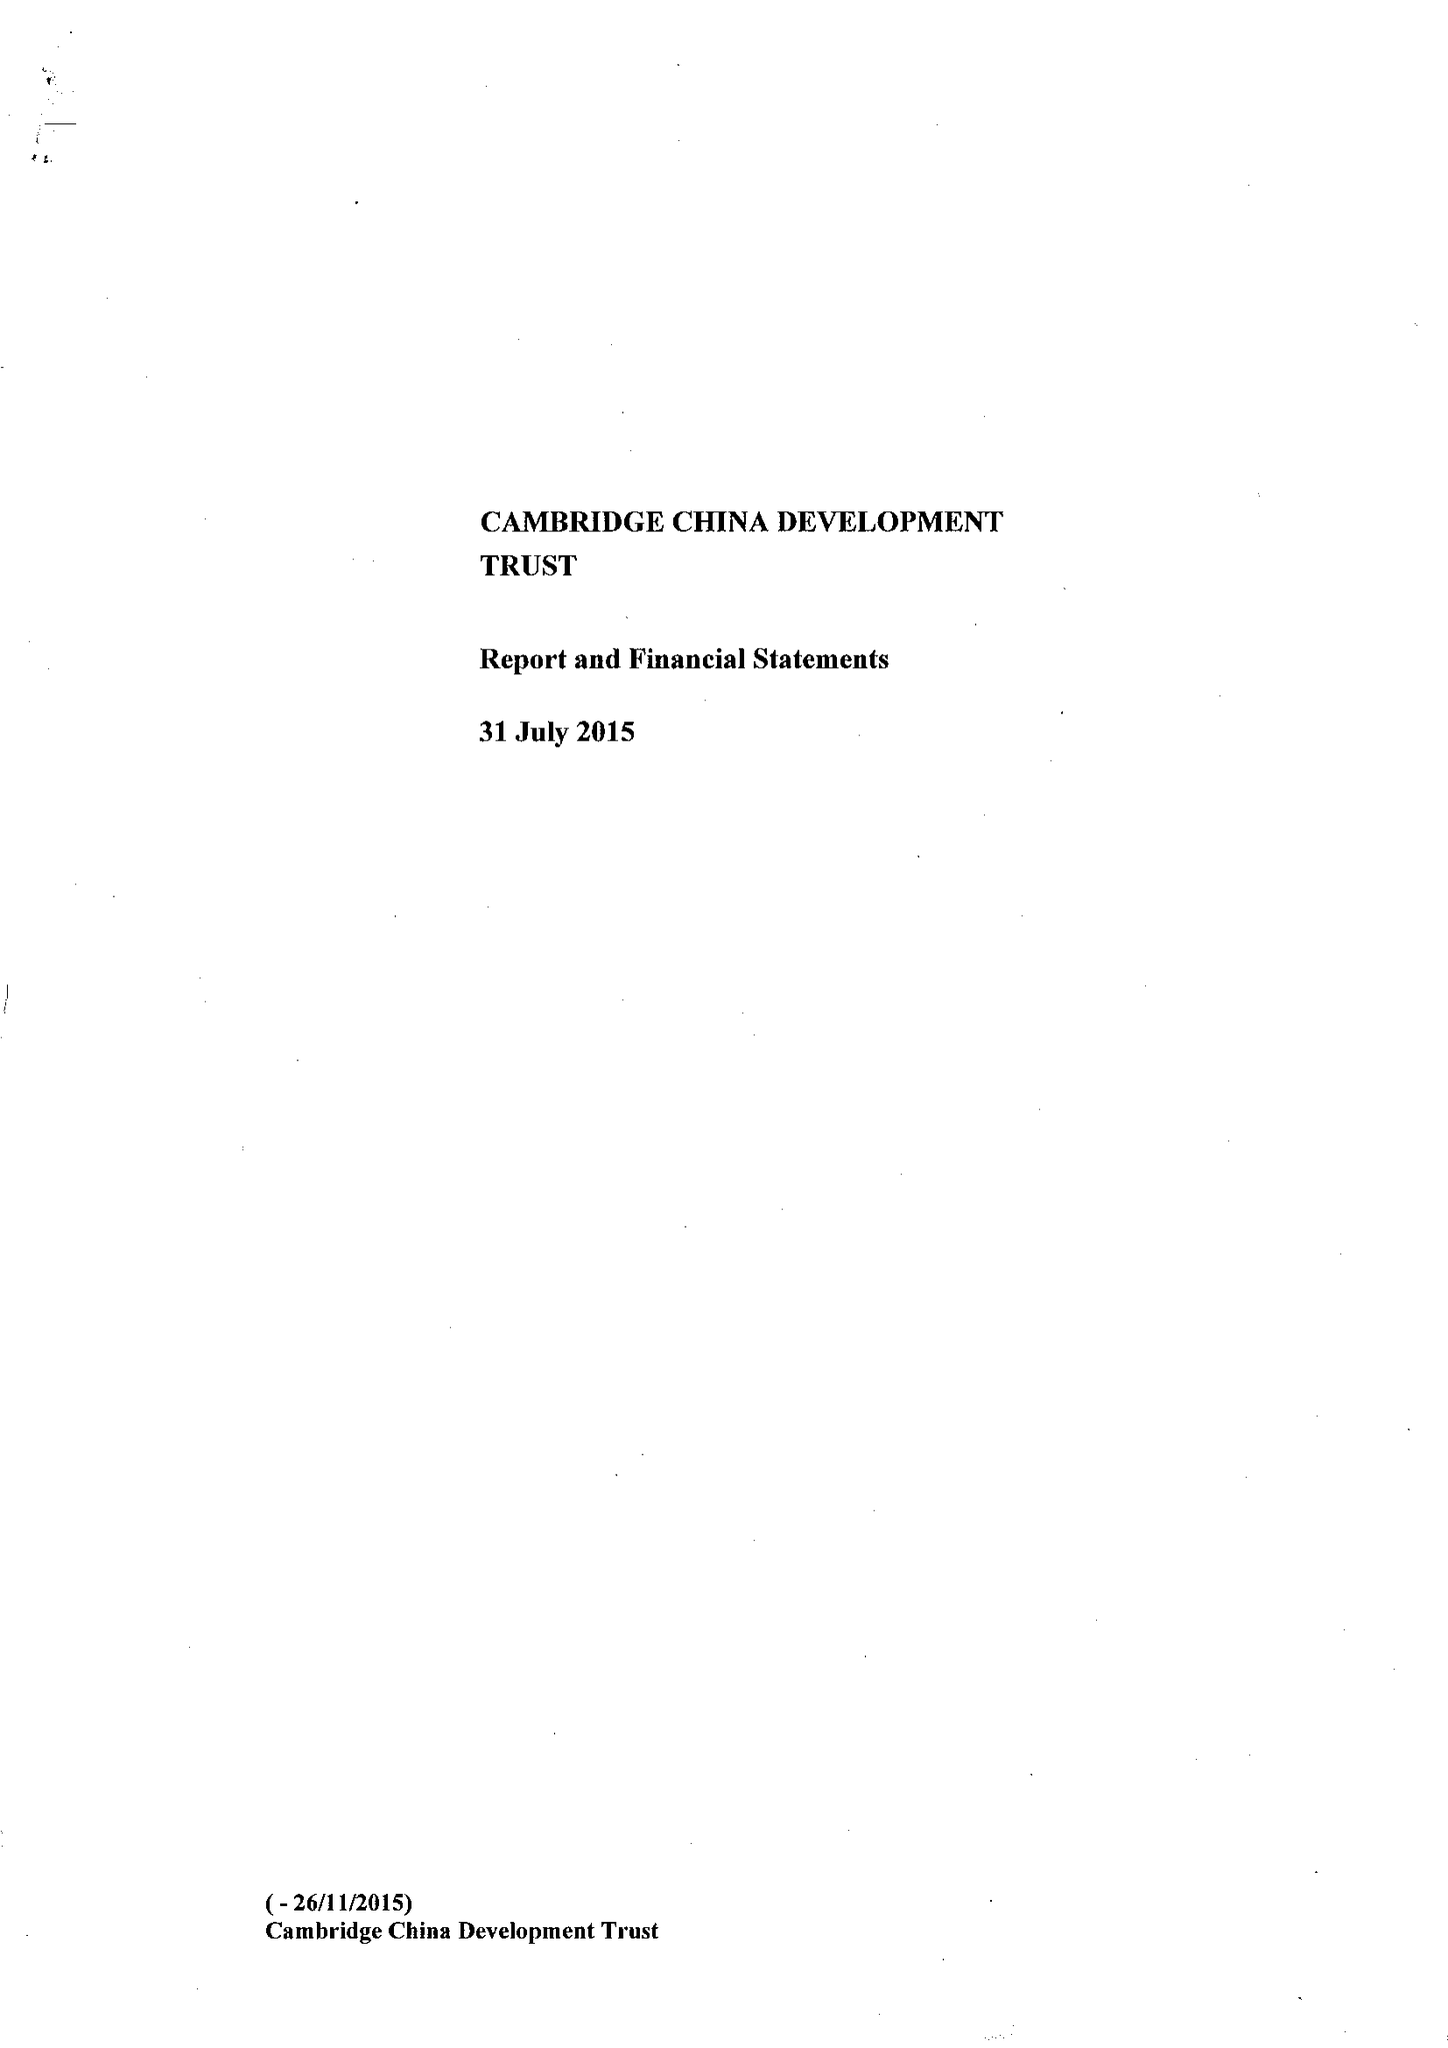What is the value for the income_annually_in_british_pounds?
Answer the question using a single word or phrase. 526211.00 